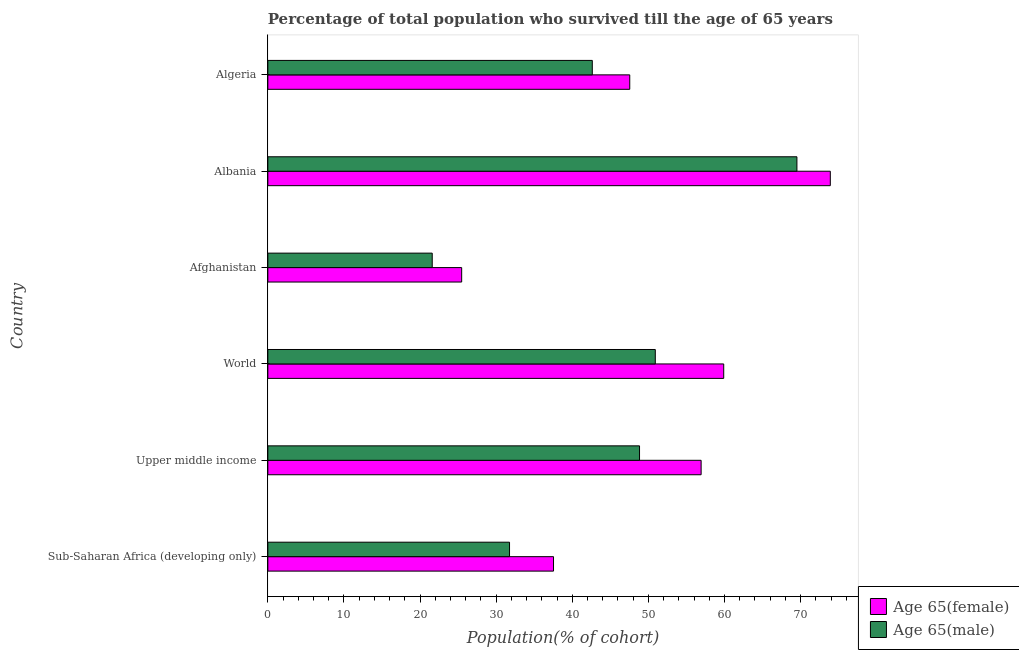How many groups of bars are there?
Make the answer very short. 6. Are the number of bars per tick equal to the number of legend labels?
Ensure brevity in your answer.  Yes. How many bars are there on the 2nd tick from the bottom?
Keep it short and to the point. 2. What is the label of the 6th group of bars from the top?
Offer a terse response. Sub-Saharan Africa (developing only). In how many cases, is the number of bars for a given country not equal to the number of legend labels?
Make the answer very short. 0. What is the percentage of female population who survived till age of 65 in Afghanistan?
Make the answer very short. 25.47. Across all countries, what is the maximum percentage of female population who survived till age of 65?
Your answer should be very brief. 73.9. Across all countries, what is the minimum percentage of female population who survived till age of 65?
Provide a succinct answer. 25.47. In which country was the percentage of female population who survived till age of 65 maximum?
Make the answer very short. Albania. In which country was the percentage of male population who survived till age of 65 minimum?
Ensure brevity in your answer.  Afghanistan. What is the total percentage of male population who survived till age of 65 in the graph?
Your answer should be very brief. 265.23. What is the difference between the percentage of female population who survived till age of 65 in Algeria and that in Sub-Saharan Africa (developing only)?
Give a very brief answer. 10.02. What is the difference between the percentage of male population who survived till age of 65 in Upper middle income and the percentage of female population who survived till age of 65 in Afghanistan?
Your response must be concise. 23.37. What is the average percentage of female population who survived till age of 65 per country?
Make the answer very short. 50.21. What is the difference between the percentage of male population who survived till age of 65 and percentage of female population who survived till age of 65 in Afghanistan?
Make the answer very short. -3.87. What is the ratio of the percentage of female population who survived till age of 65 in Afghanistan to that in Upper middle income?
Your response must be concise. 0.45. Is the percentage of male population who survived till age of 65 in Algeria less than that in Upper middle income?
Your answer should be compact. Yes. What is the difference between the highest and the second highest percentage of female population who survived till age of 65?
Make the answer very short. 14.01. What is the difference between the highest and the lowest percentage of female population who survived till age of 65?
Ensure brevity in your answer.  48.43. What does the 2nd bar from the top in Sub-Saharan Africa (developing only) represents?
Make the answer very short. Age 65(female). What does the 1st bar from the bottom in Algeria represents?
Your answer should be very brief. Age 65(female). How many bars are there?
Provide a short and direct response. 12. Where does the legend appear in the graph?
Your answer should be very brief. Bottom right. How many legend labels are there?
Keep it short and to the point. 2. How are the legend labels stacked?
Your answer should be very brief. Vertical. What is the title of the graph?
Your answer should be very brief. Percentage of total population who survived till the age of 65 years. What is the label or title of the X-axis?
Provide a short and direct response. Population(% of cohort). What is the label or title of the Y-axis?
Provide a succinct answer. Country. What is the Population(% of cohort) in Age 65(female) in Sub-Saharan Africa (developing only)?
Your response must be concise. 37.53. What is the Population(% of cohort) of Age 65(male) in Sub-Saharan Africa (developing only)?
Your answer should be very brief. 31.75. What is the Population(% of cohort) in Age 65(female) in Upper middle income?
Give a very brief answer. 56.93. What is the Population(% of cohort) of Age 65(male) in Upper middle income?
Give a very brief answer. 48.83. What is the Population(% of cohort) of Age 65(female) in World?
Provide a short and direct response. 59.9. What is the Population(% of cohort) of Age 65(male) in World?
Your answer should be very brief. 50.91. What is the Population(% of cohort) in Age 65(female) in Afghanistan?
Your answer should be very brief. 25.47. What is the Population(% of cohort) of Age 65(male) in Afghanistan?
Ensure brevity in your answer.  21.6. What is the Population(% of cohort) of Age 65(female) in Albania?
Your response must be concise. 73.9. What is the Population(% of cohort) in Age 65(male) in Albania?
Make the answer very short. 69.51. What is the Population(% of cohort) in Age 65(female) in Algeria?
Provide a succinct answer. 47.55. What is the Population(% of cohort) of Age 65(male) in Algeria?
Ensure brevity in your answer.  42.63. Across all countries, what is the maximum Population(% of cohort) in Age 65(female)?
Offer a terse response. 73.9. Across all countries, what is the maximum Population(% of cohort) in Age 65(male)?
Keep it short and to the point. 69.51. Across all countries, what is the minimum Population(% of cohort) in Age 65(female)?
Your answer should be very brief. 25.47. Across all countries, what is the minimum Population(% of cohort) of Age 65(male)?
Offer a terse response. 21.6. What is the total Population(% of cohort) in Age 65(female) in the graph?
Provide a short and direct response. 301.27. What is the total Population(% of cohort) in Age 65(male) in the graph?
Offer a very short reply. 265.23. What is the difference between the Population(% of cohort) in Age 65(female) in Sub-Saharan Africa (developing only) and that in Upper middle income?
Provide a short and direct response. -19.39. What is the difference between the Population(% of cohort) in Age 65(male) in Sub-Saharan Africa (developing only) and that in Upper middle income?
Your answer should be compact. -17.08. What is the difference between the Population(% of cohort) in Age 65(female) in Sub-Saharan Africa (developing only) and that in World?
Your answer should be compact. -22.36. What is the difference between the Population(% of cohort) of Age 65(male) in Sub-Saharan Africa (developing only) and that in World?
Ensure brevity in your answer.  -19.15. What is the difference between the Population(% of cohort) in Age 65(female) in Sub-Saharan Africa (developing only) and that in Afghanistan?
Your answer should be compact. 12.07. What is the difference between the Population(% of cohort) of Age 65(male) in Sub-Saharan Africa (developing only) and that in Afghanistan?
Provide a short and direct response. 10.16. What is the difference between the Population(% of cohort) in Age 65(female) in Sub-Saharan Africa (developing only) and that in Albania?
Ensure brevity in your answer.  -36.37. What is the difference between the Population(% of cohort) of Age 65(male) in Sub-Saharan Africa (developing only) and that in Albania?
Give a very brief answer. -37.76. What is the difference between the Population(% of cohort) of Age 65(female) in Sub-Saharan Africa (developing only) and that in Algeria?
Offer a terse response. -10.02. What is the difference between the Population(% of cohort) in Age 65(male) in Sub-Saharan Africa (developing only) and that in Algeria?
Offer a very short reply. -10.88. What is the difference between the Population(% of cohort) in Age 65(female) in Upper middle income and that in World?
Make the answer very short. -2.97. What is the difference between the Population(% of cohort) of Age 65(male) in Upper middle income and that in World?
Keep it short and to the point. -2.07. What is the difference between the Population(% of cohort) of Age 65(female) in Upper middle income and that in Afghanistan?
Ensure brevity in your answer.  31.46. What is the difference between the Population(% of cohort) in Age 65(male) in Upper middle income and that in Afghanistan?
Your response must be concise. 27.24. What is the difference between the Population(% of cohort) of Age 65(female) in Upper middle income and that in Albania?
Make the answer very short. -16.97. What is the difference between the Population(% of cohort) of Age 65(male) in Upper middle income and that in Albania?
Provide a short and direct response. -20.68. What is the difference between the Population(% of cohort) in Age 65(female) in Upper middle income and that in Algeria?
Ensure brevity in your answer.  9.38. What is the difference between the Population(% of cohort) in Age 65(male) in Upper middle income and that in Algeria?
Make the answer very short. 6.2. What is the difference between the Population(% of cohort) in Age 65(female) in World and that in Afghanistan?
Keep it short and to the point. 34.43. What is the difference between the Population(% of cohort) of Age 65(male) in World and that in Afghanistan?
Offer a terse response. 29.31. What is the difference between the Population(% of cohort) in Age 65(female) in World and that in Albania?
Your answer should be compact. -14. What is the difference between the Population(% of cohort) in Age 65(male) in World and that in Albania?
Keep it short and to the point. -18.61. What is the difference between the Population(% of cohort) of Age 65(female) in World and that in Algeria?
Your response must be concise. 12.35. What is the difference between the Population(% of cohort) in Age 65(male) in World and that in Algeria?
Your answer should be very brief. 8.28. What is the difference between the Population(% of cohort) of Age 65(female) in Afghanistan and that in Albania?
Provide a short and direct response. -48.43. What is the difference between the Population(% of cohort) of Age 65(male) in Afghanistan and that in Albania?
Offer a terse response. -47.91. What is the difference between the Population(% of cohort) of Age 65(female) in Afghanistan and that in Algeria?
Your answer should be compact. -22.08. What is the difference between the Population(% of cohort) in Age 65(male) in Afghanistan and that in Algeria?
Your response must be concise. -21.03. What is the difference between the Population(% of cohort) of Age 65(female) in Albania and that in Algeria?
Ensure brevity in your answer.  26.35. What is the difference between the Population(% of cohort) in Age 65(male) in Albania and that in Algeria?
Your answer should be very brief. 26.88. What is the difference between the Population(% of cohort) in Age 65(female) in Sub-Saharan Africa (developing only) and the Population(% of cohort) in Age 65(male) in Upper middle income?
Provide a short and direct response. -11.3. What is the difference between the Population(% of cohort) of Age 65(female) in Sub-Saharan Africa (developing only) and the Population(% of cohort) of Age 65(male) in World?
Provide a short and direct response. -13.37. What is the difference between the Population(% of cohort) of Age 65(female) in Sub-Saharan Africa (developing only) and the Population(% of cohort) of Age 65(male) in Afghanistan?
Provide a succinct answer. 15.94. What is the difference between the Population(% of cohort) in Age 65(female) in Sub-Saharan Africa (developing only) and the Population(% of cohort) in Age 65(male) in Albania?
Offer a terse response. -31.98. What is the difference between the Population(% of cohort) of Age 65(female) in Sub-Saharan Africa (developing only) and the Population(% of cohort) of Age 65(male) in Algeria?
Make the answer very short. -5.1. What is the difference between the Population(% of cohort) of Age 65(female) in Upper middle income and the Population(% of cohort) of Age 65(male) in World?
Ensure brevity in your answer.  6.02. What is the difference between the Population(% of cohort) of Age 65(female) in Upper middle income and the Population(% of cohort) of Age 65(male) in Afghanistan?
Offer a very short reply. 35.33. What is the difference between the Population(% of cohort) of Age 65(female) in Upper middle income and the Population(% of cohort) of Age 65(male) in Albania?
Your answer should be compact. -12.59. What is the difference between the Population(% of cohort) in Age 65(female) in Upper middle income and the Population(% of cohort) in Age 65(male) in Algeria?
Provide a succinct answer. 14.3. What is the difference between the Population(% of cohort) in Age 65(female) in World and the Population(% of cohort) in Age 65(male) in Afghanistan?
Your answer should be very brief. 38.3. What is the difference between the Population(% of cohort) of Age 65(female) in World and the Population(% of cohort) of Age 65(male) in Albania?
Provide a short and direct response. -9.62. What is the difference between the Population(% of cohort) of Age 65(female) in World and the Population(% of cohort) of Age 65(male) in Algeria?
Keep it short and to the point. 17.27. What is the difference between the Population(% of cohort) of Age 65(female) in Afghanistan and the Population(% of cohort) of Age 65(male) in Albania?
Your answer should be compact. -44.05. What is the difference between the Population(% of cohort) of Age 65(female) in Afghanistan and the Population(% of cohort) of Age 65(male) in Algeria?
Provide a short and direct response. -17.16. What is the difference between the Population(% of cohort) in Age 65(female) in Albania and the Population(% of cohort) in Age 65(male) in Algeria?
Your response must be concise. 31.27. What is the average Population(% of cohort) of Age 65(female) per country?
Your answer should be compact. 50.21. What is the average Population(% of cohort) in Age 65(male) per country?
Make the answer very short. 44.21. What is the difference between the Population(% of cohort) of Age 65(female) and Population(% of cohort) of Age 65(male) in Sub-Saharan Africa (developing only)?
Keep it short and to the point. 5.78. What is the difference between the Population(% of cohort) of Age 65(female) and Population(% of cohort) of Age 65(male) in Upper middle income?
Give a very brief answer. 8.09. What is the difference between the Population(% of cohort) of Age 65(female) and Population(% of cohort) of Age 65(male) in World?
Ensure brevity in your answer.  8.99. What is the difference between the Population(% of cohort) in Age 65(female) and Population(% of cohort) in Age 65(male) in Afghanistan?
Your response must be concise. 3.87. What is the difference between the Population(% of cohort) of Age 65(female) and Population(% of cohort) of Age 65(male) in Albania?
Your answer should be very brief. 4.39. What is the difference between the Population(% of cohort) of Age 65(female) and Population(% of cohort) of Age 65(male) in Algeria?
Provide a succinct answer. 4.92. What is the ratio of the Population(% of cohort) in Age 65(female) in Sub-Saharan Africa (developing only) to that in Upper middle income?
Offer a very short reply. 0.66. What is the ratio of the Population(% of cohort) of Age 65(male) in Sub-Saharan Africa (developing only) to that in Upper middle income?
Your answer should be compact. 0.65. What is the ratio of the Population(% of cohort) of Age 65(female) in Sub-Saharan Africa (developing only) to that in World?
Offer a very short reply. 0.63. What is the ratio of the Population(% of cohort) in Age 65(male) in Sub-Saharan Africa (developing only) to that in World?
Keep it short and to the point. 0.62. What is the ratio of the Population(% of cohort) of Age 65(female) in Sub-Saharan Africa (developing only) to that in Afghanistan?
Make the answer very short. 1.47. What is the ratio of the Population(% of cohort) in Age 65(male) in Sub-Saharan Africa (developing only) to that in Afghanistan?
Your answer should be compact. 1.47. What is the ratio of the Population(% of cohort) of Age 65(female) in Sub-Saharan Africa (developing only) to that in Albania?
Your answer should be compact. 0.51. What is the ratio of the Population(% of cohort) in Age 65(male) in Sub-Saharan Africa (developing only) to that in Albania?
Provide a short and direct response. 0.46. What is the ratio of the Population(% of cohort) in Age 65(female) in Sub-Saharan Africa (developing only) to that in Algeria?
Ensure brevity in your answer.  0.79. What is the ratio of the Population(% of cohort) in Age 65(male) in Sub-Saharan Africa (developing only) to that in Algeria?
Provide a succinct answer. 0.74. What is the ratio of the Population(% of cohort) of Age 65(female) in Upper middle income to that in World?
Keep it short and to the point. 0.95. What is the ratio of the Population(% of cohort) of Age 65(male) in Upper middle income to that in World?
Your answer should be very brief. 0.96. What is the ratio of the Population(% of cohort) of Age 65(female) in Upper middle income to that in Afghanistan?
Provide a short and direct response. 2.24. What is the ratio of the Population(% of cohort) of Age 65(male) in Upper middle income to that in Afghanistan?
Give a very brief answer. 2.26. What is the ratio of the Population(% of cohort) in Age 65(female) in Upper middle income to that in Albania?
Offer a very short reply. 0.77. What is the ratio of the Population(% of cohort) in Age 65(male) in Upper middle income to that in Albania?
Make the answer very short. 0.7. What is the ratio of the Population(% of cohort) of Age 65(female) in Upper middle income to that in Algeria?
Your answer should be compact. 1.2. What is the ratio of the Population(% of cohort) in Age 65(male) in Upper middle income to that in Algeria?
Give a very brief answer. 1.15. What is the ratio of the Population(% of cohort) of Age 65(female) in World to that in Afghanistan?
Your response must be concise. 2.35. What is the ratio of the Population(% of cohort) of Age 65(male) in World to that in Afghanistan?
Offer a terse response. 2.36. What is the ratio of the Population(% of cohort) in Age 65(female) in World to that in Albania?
Offer a terse response. 0.81. What is the ratio of the Population(% of cohort) of Age 65(male) in World to that in Albania?
Your answer should be compact. 0.73. What is the ratio of the Population(% of cohort) of Age 65(female) in World to that in Algeria?
Ensure brevity in your answer.  1.26. What is the ratio of the Population(% of cohort) in Age 65(male) in World to that in Algeria?
Provide a short and direct response. 1.19. What is the ratio of the Population(% of cohort) of Age 65(female) in Afghanistan to that in Albania?
Give a very brief answer. 0.34. What is the ratio of the Population(% of cohort) in Age 65(male) in Afghanistan to that in Albania?
Your answer should be compact. 0.31. What is the ratio of the Population(% of cohort) of Age 65(female) in Afghanistan to that in Algeria?
Give a very brief answer. 0.54. What is the ratio of the Population(% of cohort) of Age 65(male) in Afghanistan to that in Algeria?
Your answer should be very brief. 0.51. What is the ratio of the Population(% of cohort) in Age 65(female) in Albania to that in Algeria?
Your answer should be compact. 1.55. What is the ratio of the Population(% of cohort) in Age 65(male) in Albania to that in Algeria?
Keep it short and to the point. 1.63. What is the difference between the highest and the second highest Population(% of cohort) in Age 65(female)?
Provide a short and direct response. 14. What is the difference between the highest and the second highest Population(% of cohort) in Age 65(male)?
Keep it short and to the point. 18.61. What is the difference between the highest and the lowest Population(% of cohort) of Age 65(female)?
Your answer should be very brief. 48.43. What is the difference between the highest and the lowest Population(% of cohort) in Age 65(male)?
Your answer should be compact. 47.91. 